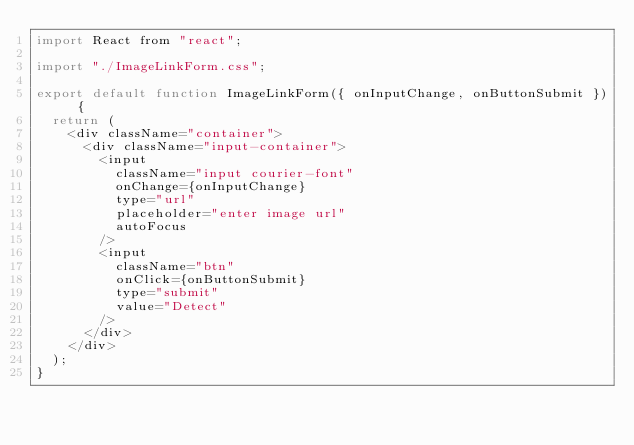Convert code to text. <code><loc_0><loc_0><loc_500><loc_500><_JavaScript_>import React from "react";

import "./ImageLinkForm.css";

export default function ImageLinkForm({ onInputChange, onButtonSubmit }) {
  return (
    <div className="container">
      <div className="input-container">
        <input
          className="input courier-font"
          onChange={onInputChange}
          type="url"
          placeholder="enter image url"
          autoFocus
        />
        <input
          className="btn"
          onClick={onButtonSubmit}
          type="submit"
          value="Detect"
        />
      </div>
    </div>
  );
}
</code> 